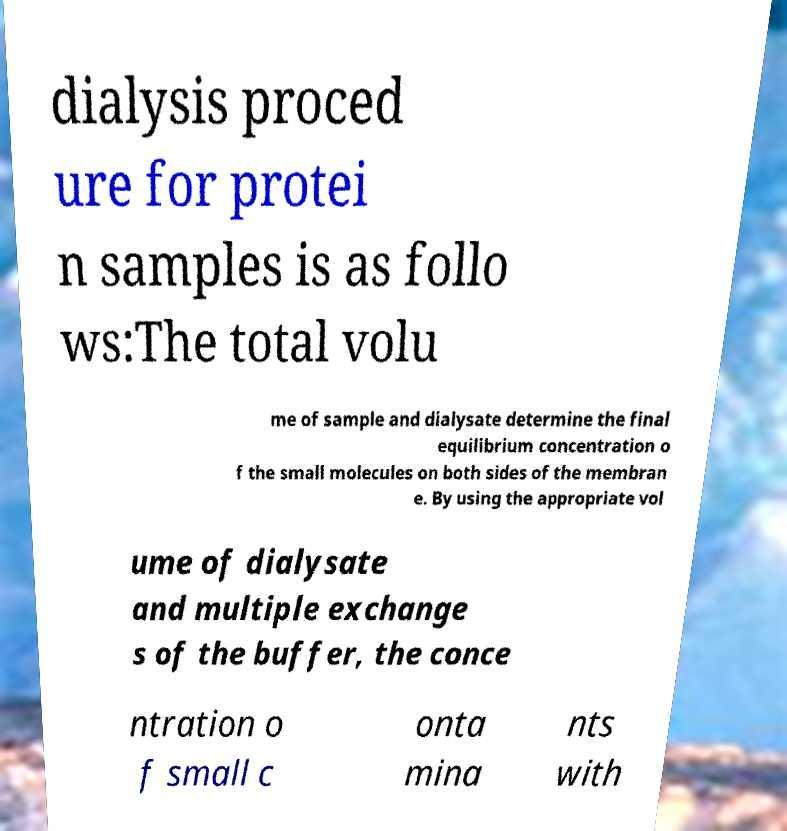Can you accurately transcribe the text from the provided image for me? dialysis proced ure for protei n samples is as follo ws:The total volu me of sample and dialysate determine the final equilibrium concentration o f the small molecules on both sides of the membran e. By using the appropriate vol ume of dialysate and multiple exchange s of the buffer, the conce ntration o f small c onta mina nts with 